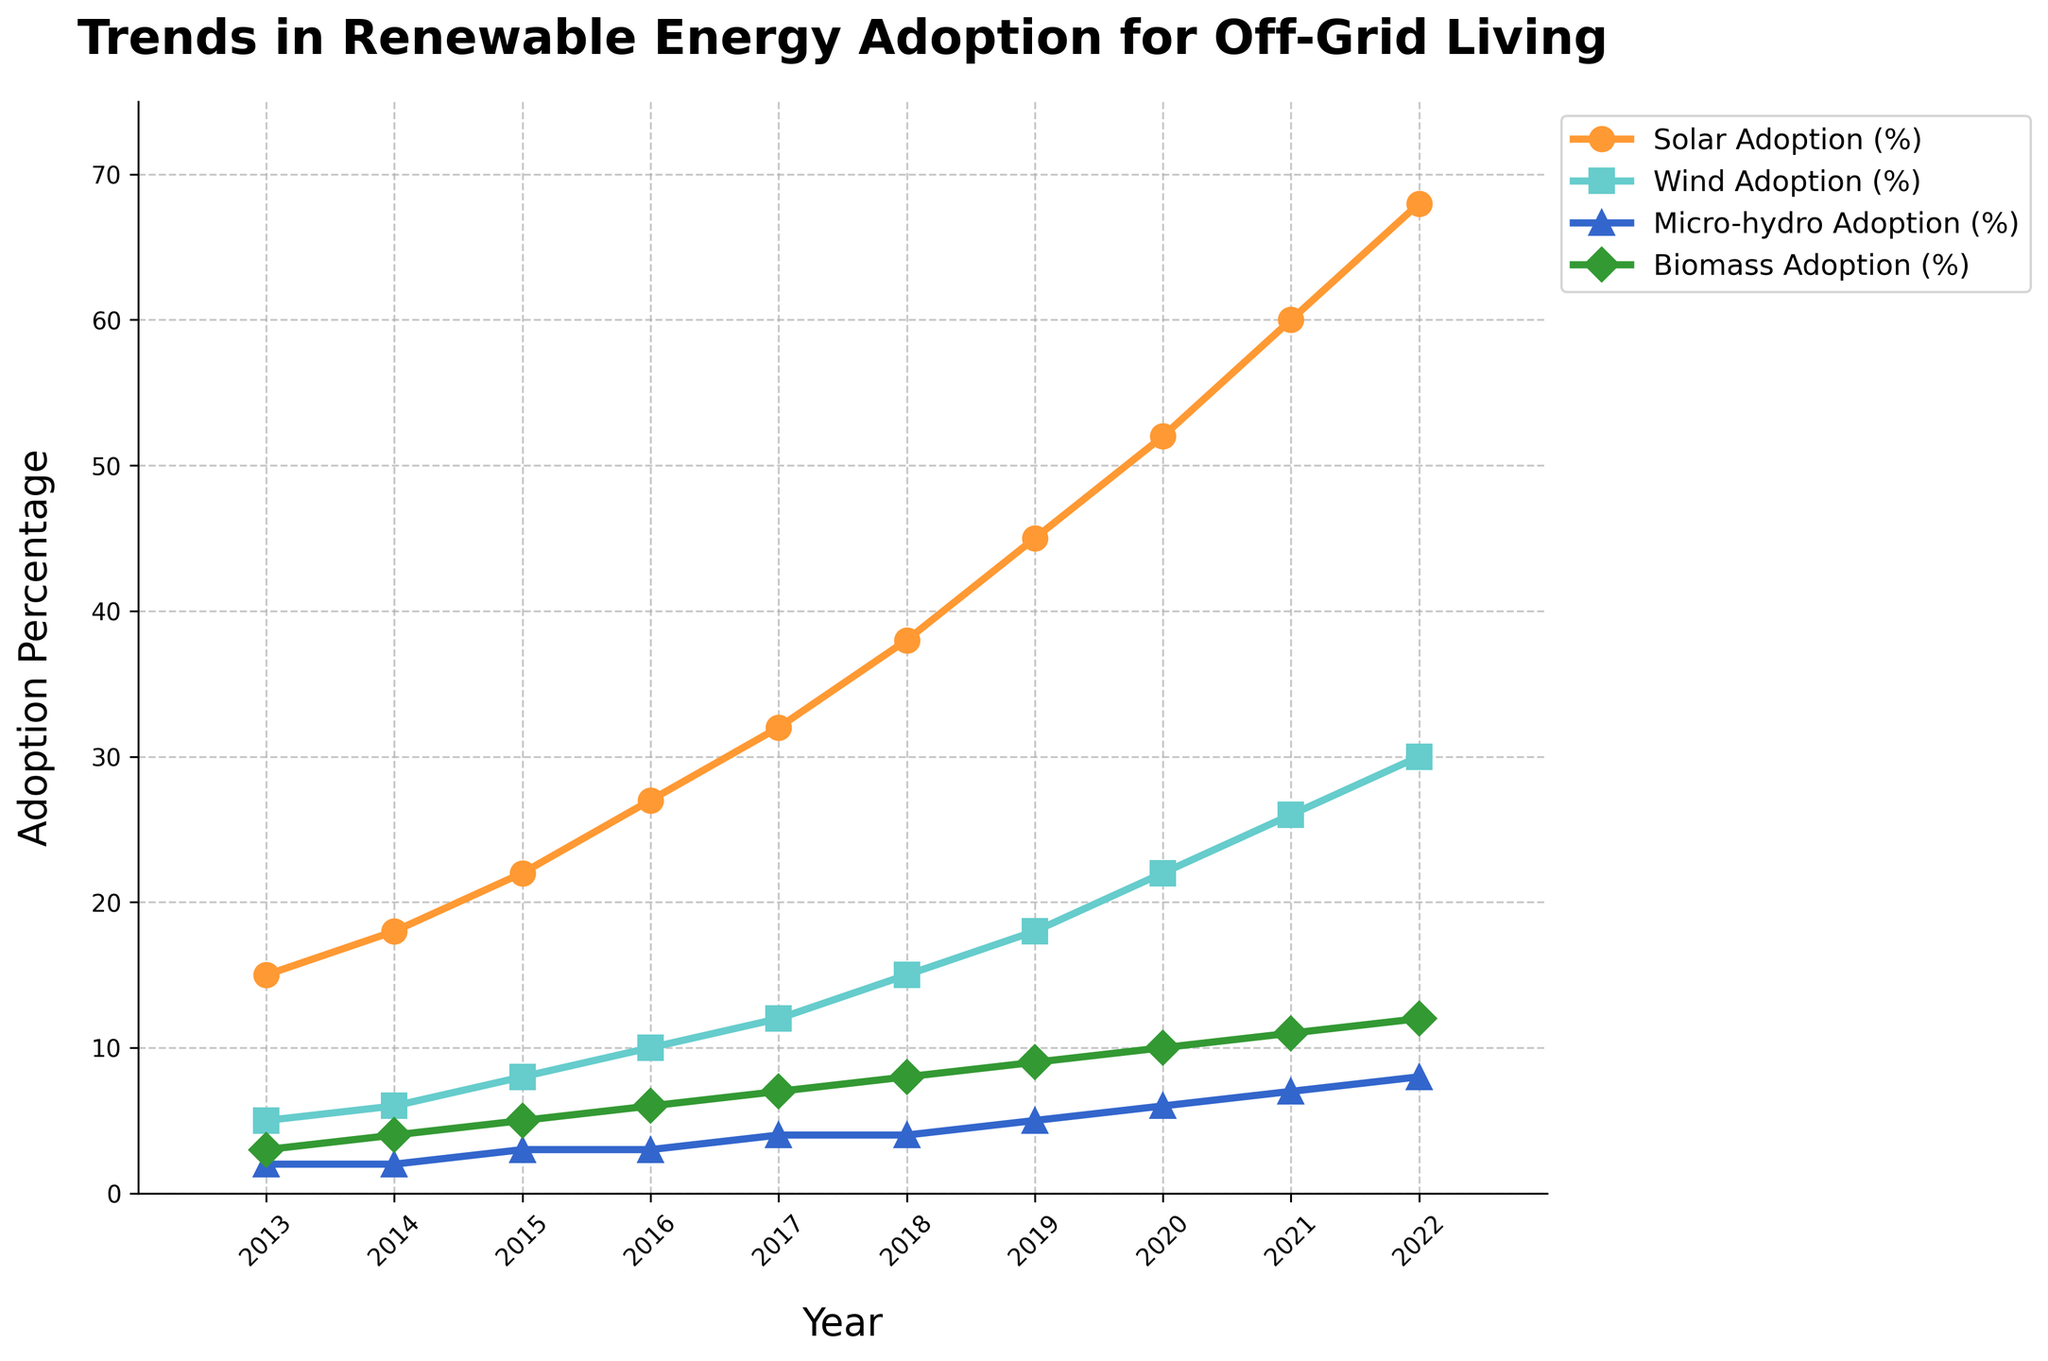What was the percentage increase in solar adoption from 2013 to 2022? Solar adoption increased from 15% in 2013 to 68% in 2022. The increase is calculated as 68% - 15% = 53%.
Answer: 53% Which renewable energy source had the lowest adoption rate in 2022? In 2022, the renewable energy source with the lowest adoption rate was Micro-hydro, at 8%.
Answer: Micro-hydro By how many percentage points did wind adoption increase between 2015 and 2020? Wind adoption increased from 8% in 2015 to 22% in 2020. The increase is calculated as 22% - 8% = 14%.
Answer: 14% Which energy source showed a consistent yearly increase in adoption percentage? All four energy sources (Solar, Wind, Micro-hydro, and Biomass) showed a consistent yearly increase from 2013 to 2022.
Answer: Solar, Wind, Micro-hydro, and Biomass In what year did solar adoption cross the 50% threshold? Solar adoption crossed the 50% threshold in 2020, reaching 52%.
Answer: 2020 How much more was the biomass adoption percentage compared to micro-hydro in 2019? In 2019, biomass adoption was 9% whereas micro-hydro was 5%. The difference is calculated as 9% - 5% = 4%.
Answer: 4% Compare the growth rates of solar and wind adoption from 2016 to 2022. Which grew faster? Solar adoption grew from 27% in 2016 to 68% in 2022, a growth of 41 percentage points. Wind adoption grew from 10% in 2016 to 30% in 2022, a growth of 20 percentage points. Therefore, Solar grew faster.
Answer: Solar What is the average adoption rate of micro-hydro over the decade? To find the average, sum the micro-hydro adoption percentages from 2013 to 2022 and divide by the number of years: (2 + 2 + 3 + 3 + 4 + 4 + 5 + 6 + 7 + 8)/10 = 4.4%.
Answer: 4.4% Which year saw the biggest single-year increase in wind adoption? The largest single-year increase in wind adoption occurred from 2019 to 2020, where it increased from 18% to 22%, an increase of 4 percentage points.
Answer: 2019 to 2020 What is the cumulative adoption percentage of all renewable sources in 2021? The cumulative adoption for 2021 is the sum of Solar (60%), Wind (26%), Micro-hydro (7%), and Biomass (11%): 60% + 26% + 7% + 11% = 104%.
Answer: 104% 